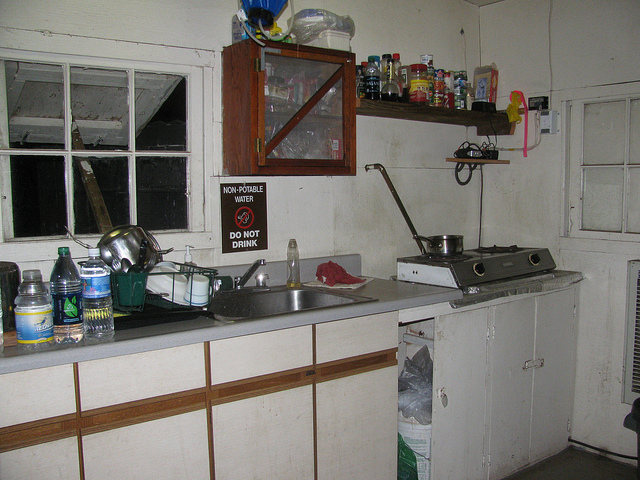Read and extract the text from this image. NON POTABLE WATER DO NOT DRINK 